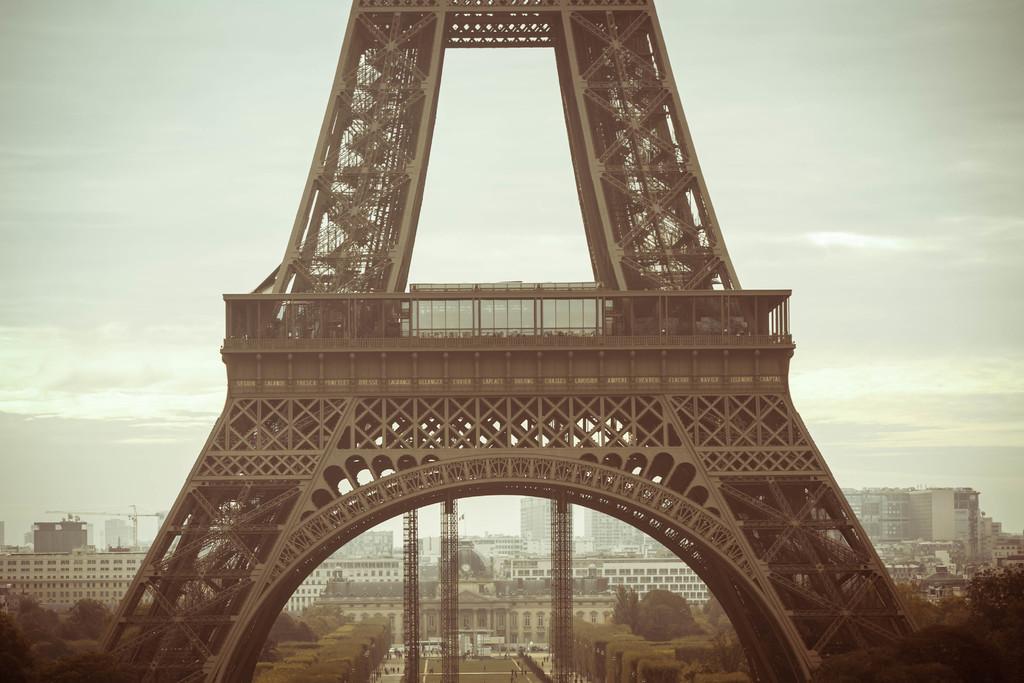In one or two sentences, can you explain what this image depicts? In this image there are towers, trees, buildings, people, road, cloudy sky and objects. 